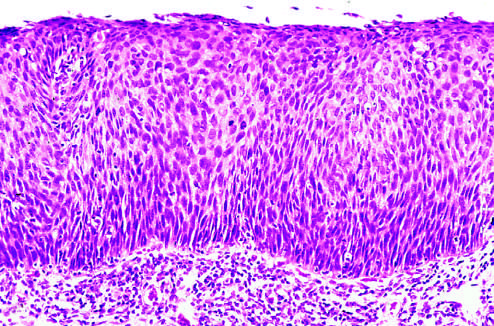what is replaced by atypical dysplastic cells?
Answer the question using a single word or phrase. The entire thickness of the epithelium cells 